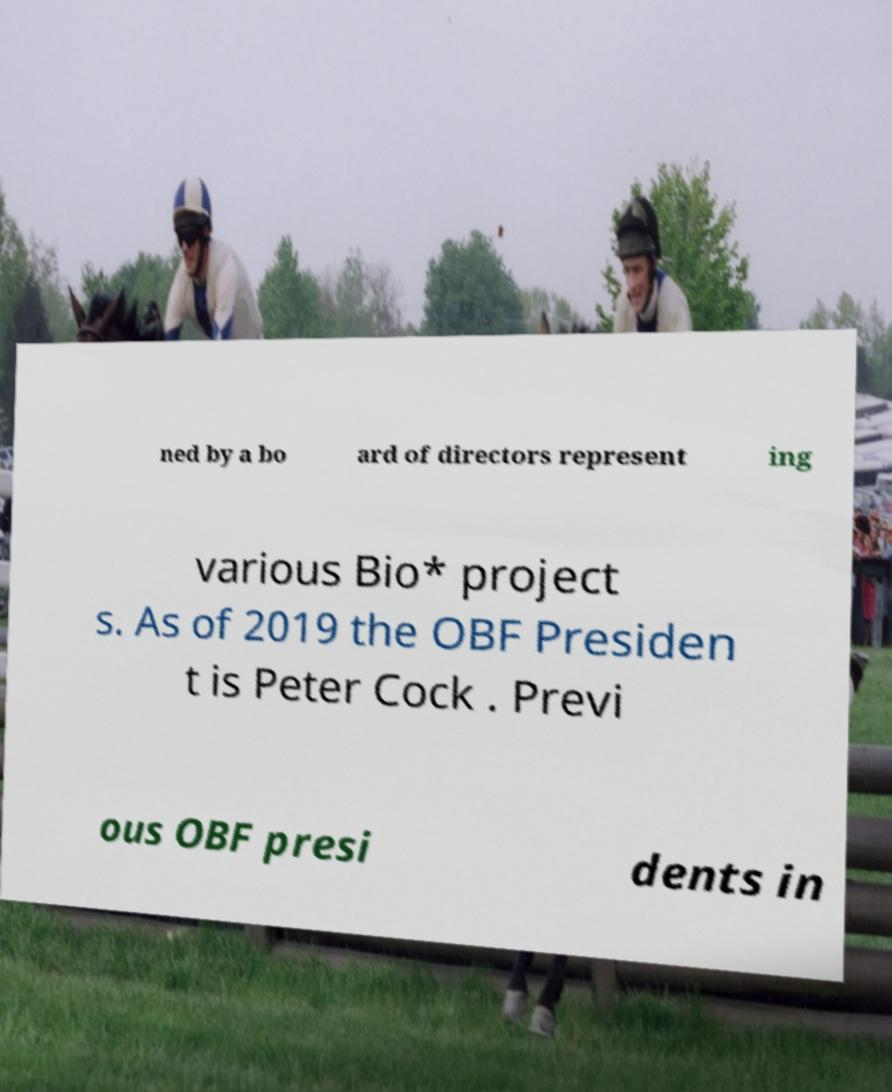Please read and relay the text visible in this image. What does it say? ned by a bo ard of directors represent ing various Bio* project s. As of 2019 the OBF Presiden t is Peter Cock . Previ ous OBF presi dents in 